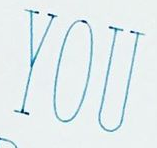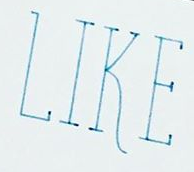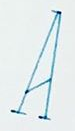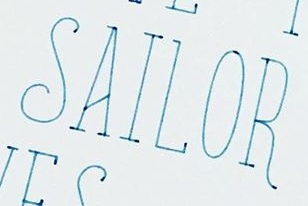Read the text from these images in sequence, separated by a semicolon. YOU; LIKE; A; SAILOR 